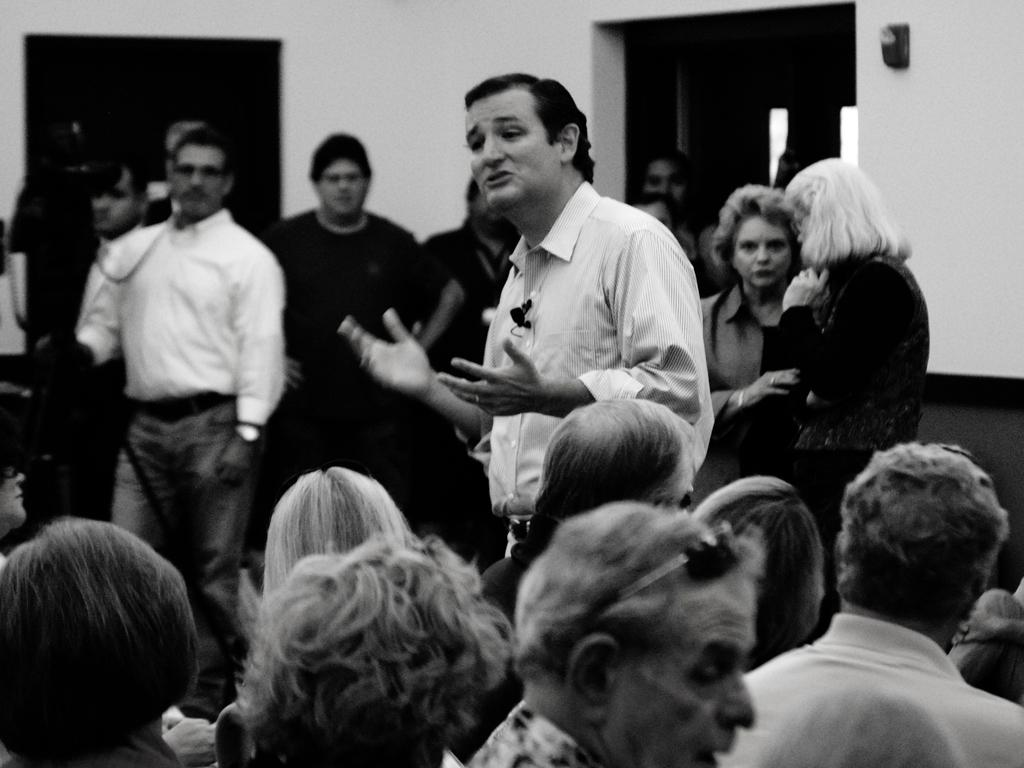What are the people in the image doing? There are people sitting and standing in the image. What is the color scheme of the image? The image is black and white. What type of ray can be seen swimming in the image? There is no ray present in the image; it only features people sitting and standing. What grade level is the image intended for? The image does not have a specific grade level associated with it, as it is a simple black and white image of people sitting and standing. 